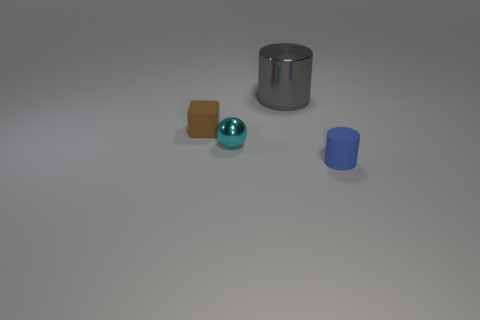There is a tiny thing that is both in front of the small brown rubber block and to the left of the blue matte cylinder; what color is it?
Offer a terse response. Cyan. What number of other objects are there of the same shape as the large gray thing?
Offer a very short reply. 1. Is the number of metal cylinders in front of the small sphere less than the number of small cylinders on the right side of the large gray metallic cylinder?
Give a very brief answer. Yes. Are the small brown cube and the thing that is to the right of the big shiny object made of the same material?
Give a very brief answer. Yes. Are there more gray metallic cylinders than tiny green rubber balls?
Give a very brief answer. Yes. There is a small rubber object in front of the matte object behind the shiny thing in front of the tiny brown rubber cube; what shape is it?
Your response must be concise. Cylinder. Does the cylinder that is on the left side of the tiny blue thing have the same material as the cyan object in front of the tiny brown rubber object?
Provide a short and direct response. Yes. There is a tiny object that is the same material as the gray cylinder; what is its shape?
Provide a succinct answer. Sphere. What number of tiny green rubber spheres are there?
Offer a very short reply. 0. What material is the cylinder to the left of the cylinder in front of the small brown object?
Provide a succinct answer. Metal. 